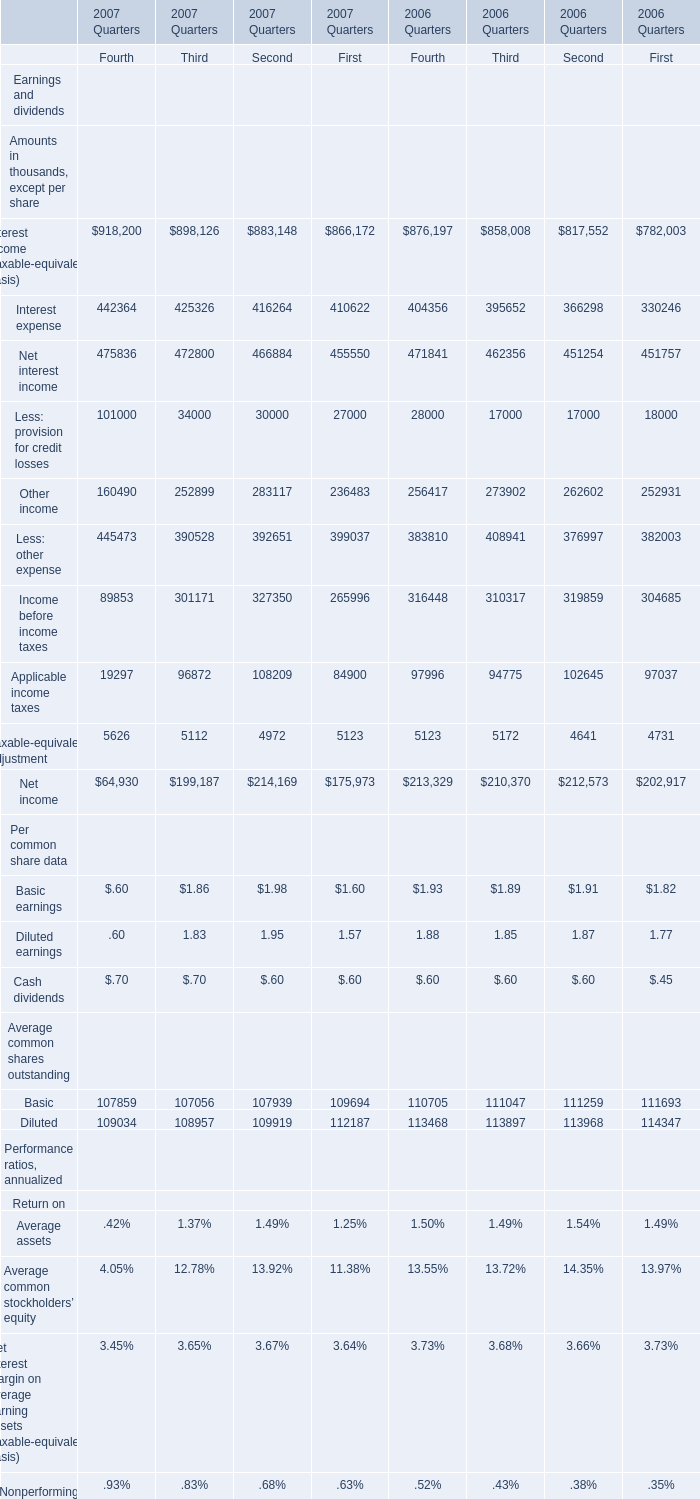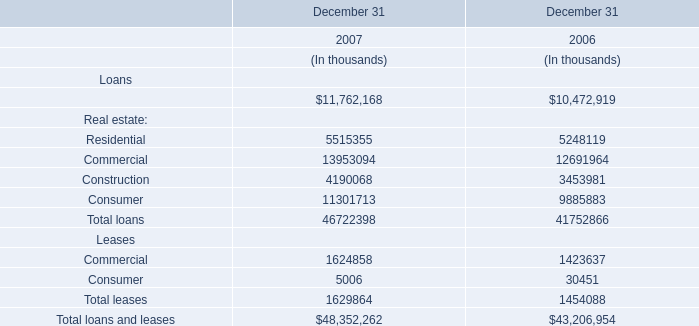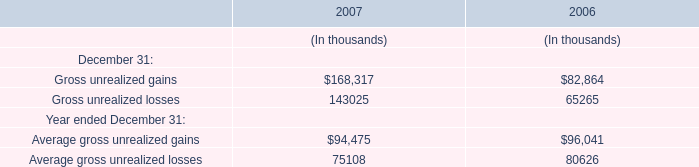What's the average of the Gross unrealized gains in the years where Residential is positive? 
Computations: ((168317 + 82864) / 2)
Answer: 125590.5. 